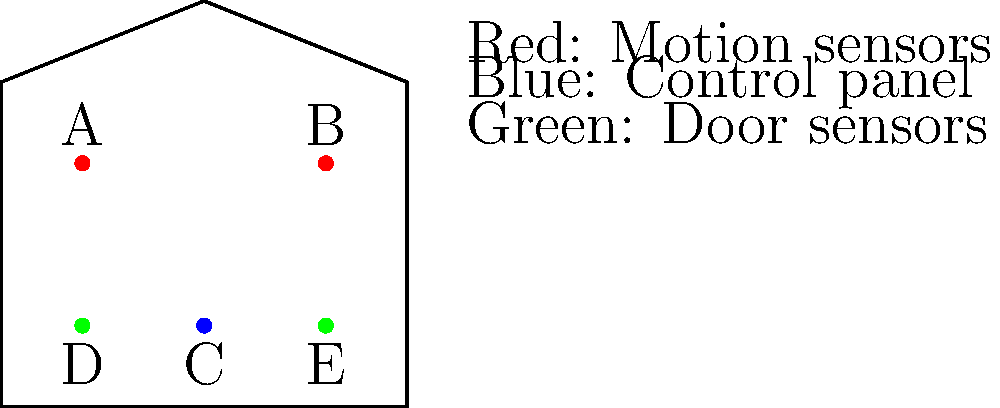As the staff member responsible for managing the business tycoon's residential needs, you've been given a schematic of the home security system. Based on the diagram, which component is most likely to be the central control panel for the entire system? To determine the central control panel, let's analyze the components in the schematic:

1. Red dots (A and B): These are labeled as motion sensors in the legend. They are typically placed high on walls to detect movement, which matches their positions in the diagram.

2. Green dots (D and E): These are labeled as door sensors in the legend. Their positions at the bottom corners of the house outline suggest they are placed near entry points.

3. Blue dot (C): This is the only blue component in the diagram, and it's centrally located.

Given this information, we can deduce:

1. Motion sensors and door sensors are input devices that send signals to a central unit.
2. The central control panel is typically a unique component that manages all other devices.
3. The blue dot (C) is centrally located, which is ideal for a control panel to receive signals from all sensors.

Therefore, the blue dot (C) is most likely to be the central control panel for the entire system.
Answer: C 